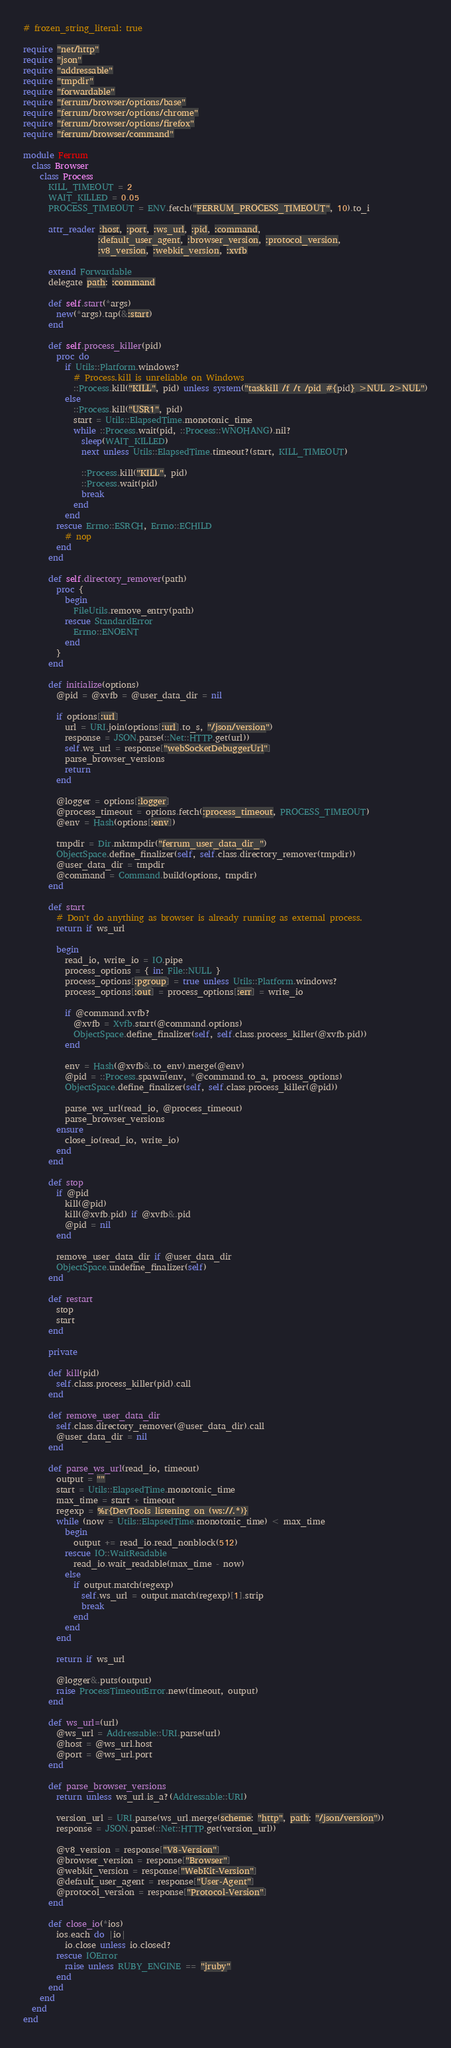Convert code to text. <code><loc_0><loc_0><loc_500><loc_500><_Ruby_># frozen_string_literal: true

require "net/http"
require "json"
require "addressable"
require "tmpdir"
require "forwardable"
require "ferrum/browser/options/base"
require "ferrum/browser/options/chrome"
require "ferrum/browser/options/firefox"
require "ferrum/browser/command"

module Ferrum
  class Browser
    class Process
      KILL_TIMEOUT = 2
      WAIT_KILLED = 0.05
      PROCESS_TIMEOUT = ENV.fetch("FERRUM_PROCESS_TIMEOUT", 10).to_i

      attr_reader :host, :port, :ws_url, :pid, :command,
                  :default_user_agent, :browser_version, :protocol_version,
                  :v8_version, :webkit_version, :xvfb

      extend Forwardable
      delegate path: :command

      def self.start(*args)
        new(*args).tap(&:start)
      end

      def self.process_killer(pid)
        proc do
          if Utils::Platform.windows?
            # Process.kill is unreliable on Windows
            ::Process.kill("KILL", pid) unless system("taskkill /f /t /pid #{pid} >NUL 2>NUL")
          else
            ::Process.kill("USR1", pid)
            start = Utils::ElapsedTime.monotonic_time
            while ::Process.wait(pid, ::Process::WNOHANG).nil?
              sleep(WAIT_KILLED)
              next unless Utils::ElapsedTime.timeout?(start, KILL_TIMEOUT)

              ::Process.kill("KILL", pid)
              ::Process.wait(pid)
              break
            end
          end
        rescue Errno::ESRCH, Errno::ECHILD
          # nop
        end
      end

      def self.directory_remover(path)
        proc {
          begin
            FileUtils.remove_entry(path)
          rescue StandardError
            Errno::ENOENT
          end
        }
      end

      def initialize(options)
        @pid = @xvfb = @user_data_dir = nil

        if options[:url]
          url = URI.join(options[:url].to_s, "/json/version")
          response = JSON.parse(::Net::HTTP.get(url))
          self.ws_url = response["webSocketDebuggerUrl"]
          parse_browser_versions
          return
        end

        @logger = options[:logger]
        @process_timeout = options.fetch(:process_timeout, PROCESS_TIMEOUT)
        @env = Hash(options[:env])

        tmpdir = Dir.mktmpdir("ferrum_user_data_dir_")
        ObjectSpace.define_finalizer(self, self.class.directory_remover(tmpdir))
        @user_data_dir = tmpdir
        @command = Command.build(options, tmpdir)
      end

      def start
        # Don't do anything as browser is already running as external process.
        return if ws_url

        begin
          read_io, write_io = IO.pipe
          process_options = { in: File::NULL }
          process_options[:pgroup] = true unless Utils::Platform.windows?
          process_options[:out] = process_options[:err] = write_io

          if @command.xvfb?
            @xvfb = Xvfb.start(@command.options)
            ObjectSpace.define_finalizer(self, self.class.process_killer(@xvfb.pid))
          end

          env = Hash(@xvfb&.to_env).merge(@env)
          @pid = ::Process.spawn(env, *@command.to_a, process_options)
          ObjectSpace.define_finalizer(self, self.class.process_killer(@pid))

          parse_ws_url(read_io, @process_timeout)
          parse_browser_versions
        ensure
          close_io(read_io, write_io)
        end
      end

      def stop
        if @pid
          kill(@pid)
          kill(@xvfb.pid) if @xvfb&.pid
          @pid = nil
        end

        remove_user_data_dir if @user_data_dir
        ObjectSpace.undefine_finalizer(self)
      end

      def restart
        stop
        start
      end

      private

      def kill(pid)
        self.class.process_killer(pid).call
      end

      def remove_user_data_dir
        self.class.directory_remover(@user_data_dir).call
        @user_data_dir = nil
      end

      def parse_ws_url(read_io, timeout)
        output = ""
        start = Utils::ElapsedTime.monotonic_time
        max_time = start + timeout
        regexp = %r{DevTools listening on (ws://.*)}
        while (now = Utils::ElapsedTime.monotonic_time) < max_time
          begin
            output += read_io.read_nonblock(512)
          rescue IO::WaitReadable
            read_io.wait_readable(max_time - now)
          else
            if output.match(regexp)
              self.ws_url = output.match(regexp)[1].strip
              break
            end
          end
        end

        return if ws_url

        @logger&.puts(output)
        raise ProcessTimeoutError.new(timeout, output)
      end

      def ws_url=(url)
        @ws_url = Addressable::URI.parse(url)
        @host = @ws_url.host
        @port = @ws_url.port
      end

      def parse_browser_versions
        return unless ws_url.is_a?(Addressable::URI)

        version_url = URI.parse(ws_url.merge(scheme: "http", path: "/json/version"))
        response = JSON.parse(::Net::HTTP.get(version_url))

        @v8_version = response["V8-Version"]
        @browser_version = response["Browser"]
        @webkit_version = response["WebKit-Version"]
        @default_user_agent = response["User-Agent"]
        @protocol_version = response["Protocol-Version"]
      end

      def close_io(*ios)
        ios.each do |io|
          io.close unless io.closed?
        rescue IOError
          raise unless RUBY_ENGINE == "jruby"
        end
      end
    end
  end
end
</code> 